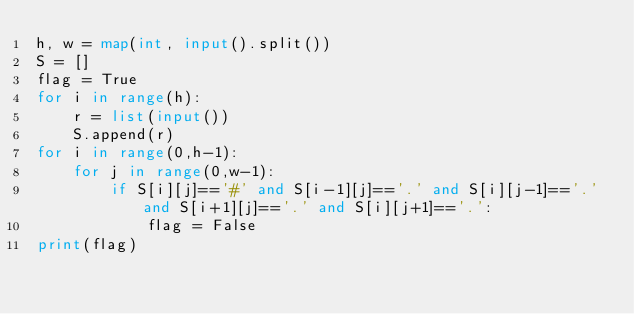Convert code to text. <code><loc_0><loc_0><loc_500><loc_500><_Python_>h, w = map(int, input().split())
S = []
flag = True
for i in range(h):
    r = list(input())
    S.append(r)
for i in range(0,h-1):
    for j in range(0,w-1):
        if S[i][j]=='#' and S[i-1][j]=='.' and S[i][j-1]=='.' and S[i+1][j]=='.' and S[i][j+1]=='.':
            flag = False
print(flag)</code> 